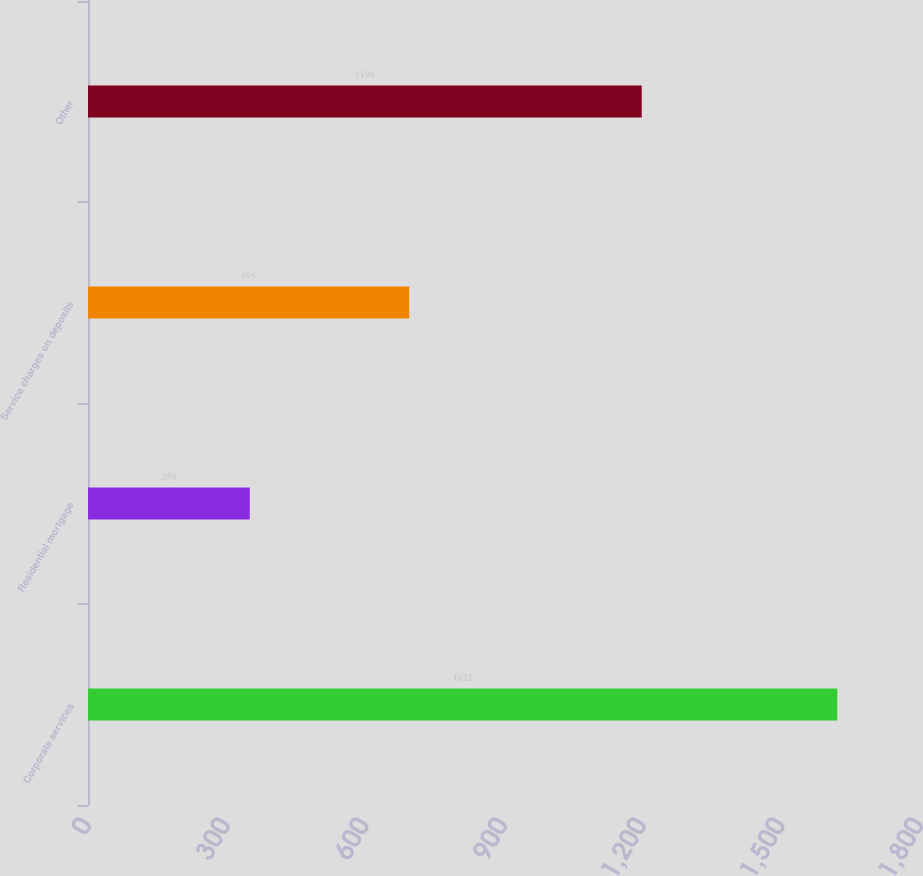Convert chart to OTSL. <chart><loc_0><loc_0><loc_500><loc_500><bar_chart><fcel>Corporate services<fcel>Residential mortgage<fcel>Service charges on deposits<fcel>Other<nl><fcel>1621<fcel>350<fcel>695<fcel>1198<nl></chart> 